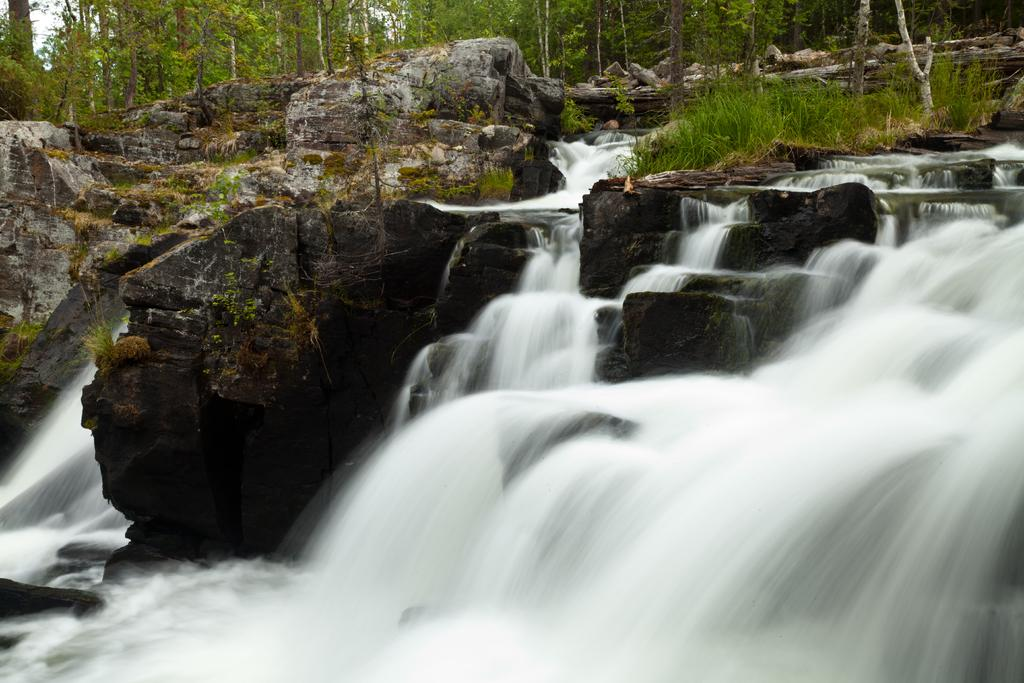What natural feature is the main subject of the image? There is a waterfall in the image. What type of geological formations can be seen in the image? Rocks are visible in the image. What type of vegetation is present in the image? There are trees and grass in the image. Where is the nearest shop or store located in the image? There is no shop or store present in the image; it features a natural scene with a waterfall, rocks, trees, and grass. 